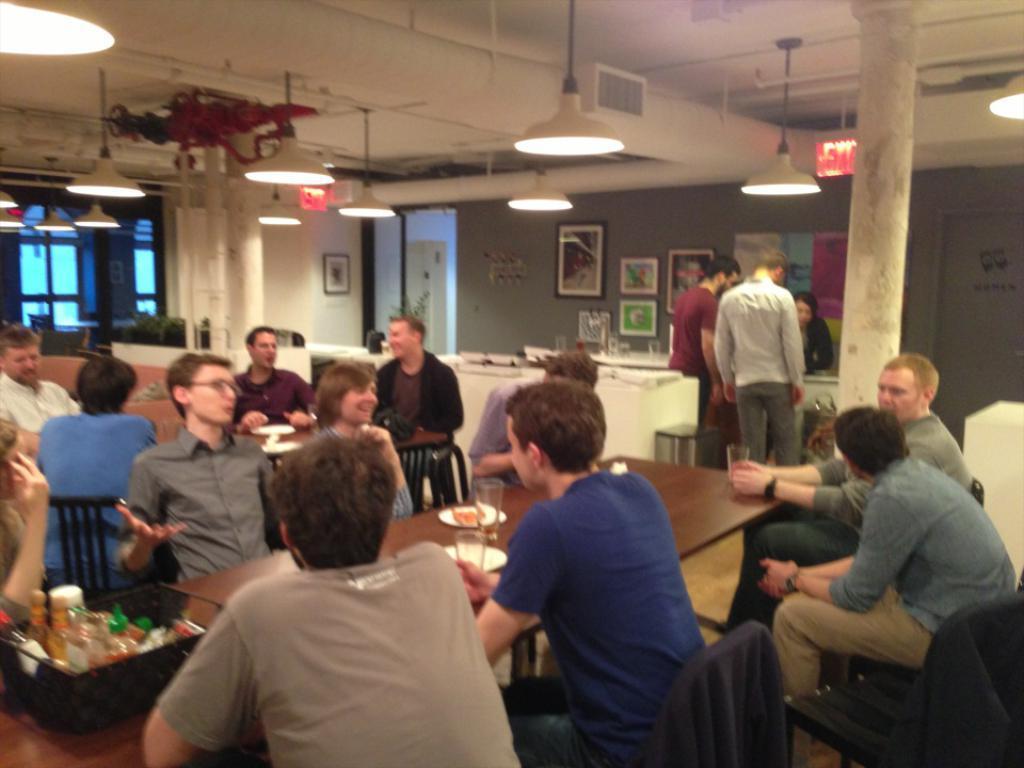Please provide a concise description of this image. In this image there are few people sitting in the chairs around the tables and talking with each other. On the table there are plates,trays in which there are bottles. At the top there are lights which are hanged to the ceiling. On the right side there is a wall to which there are photo frames. In the background there is a window. Beside the window there is a pillar. At the top there are pipes. 